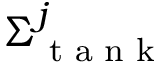<formula> <loc_0><loc_0><loc_500><loc_500>\Sigma _ { t a n k } ^ { j }</formula> 